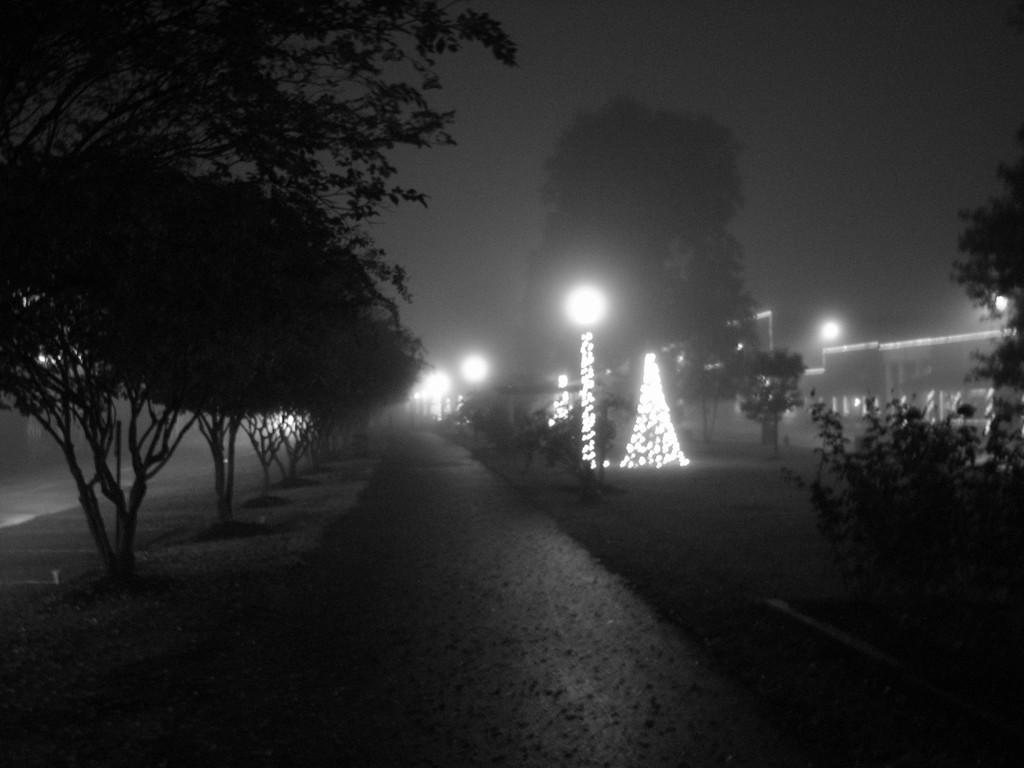What type of vegetation can be seen in the image? There are trees in the image. What is visible beneath the trees? There is ground visible in the image. What can be seen between the trees? There are lights between the trees. What is visible in the background of the image? There is a building and the sky visible in the background of the image. What type of knife is being used by the mice in the image? There are no mice or knives present in the image. 